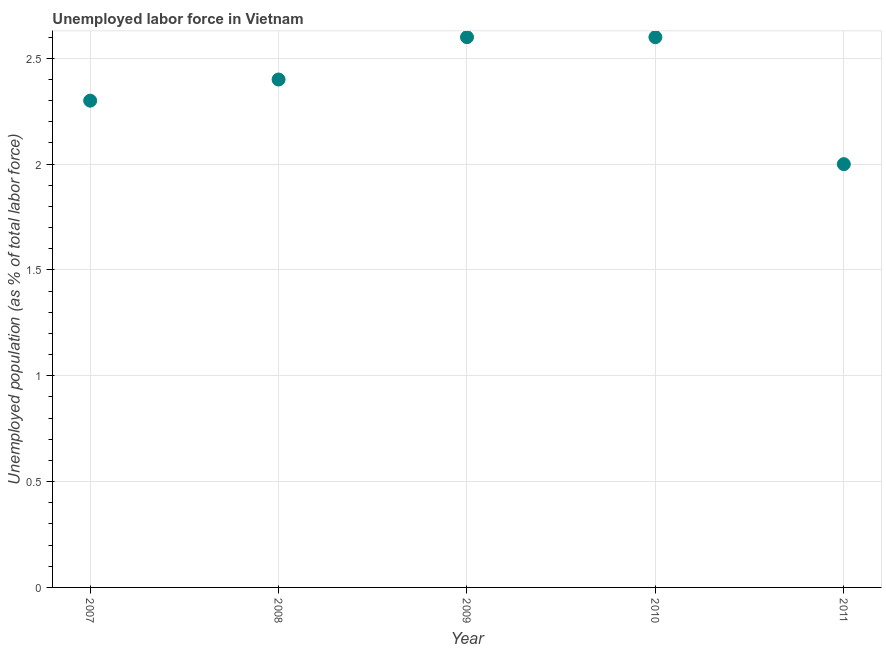What is the total unemployed population in 2007?
Your answer should be compact. 2.3. Across all years, what is the maximum total unemployed population?
Give a very brief answer. 2.6. Across all years, what is the minimum total unemployed population?
Offer a terse response. 2. In which year was the total unemployed population minimum?
Make the answer very short. 2011. What is the sum of the total unemployed population?
Provide a short and direct response. 11.9. What is the difference between the total unemployed population in 2008 and 2010?
Give a very brief answer. -0.2. What is the average total unemployed population per year?
Make the answer very short. 2.38. What is the median total unemployed population?
Provide a short and direct response. 2.4. In how many years, is the total unemployed population greater than 1 %?
Your answer should be very brief. 5. Do a majority of the years between 2009 and 2007 (inclusive) have total unemployed population greater than 1.5 %?
Give a very brief answer. No. What is the ratio of the total unemployed population in 2010 to that in 2011?
Ensure brevity in your answer.  1.3. Is the total unemployed population in 2008 less than that in 2010?
Provide a succinct answer. Yes. What is the difference between the highest and the second highest total unemployed population?
Give a very brief answer. 0. What is the difference between the highest and the lowest total unemployed population?
Your response must be concise. 0.6. How many dotlines are there?
Make the answer very short. 1. How many years are there in the graph?
Your answer should be very brief. 5. What is the difference between two consecutive major ticks on the Y-axis?
Give a very brief answer. 0.5. Does the graph contain grids?
Your response must be concise. Yes. What is the title of the graph?
Ensure brevity in your answer.  Unemployed labor force in Vietnam. What is the label or title of the Y-axis?
Your response must be concise. Unemployed population (as % of total labor force). What is the Unemployed population (as % of total labor force) in 2007?
Offer a terse response. 2.3. What is the Unemployed population (as % of total labor force) in 2008?
Offer a very short reply. 2.4. What is the Unemployed population (as % of total labor force) in 2009?
Ensure brevity in your answer.  2.6. What is the Unemployed population (as % of total labor force) in 2010?
Provide a succinct answer. 2.6. What is the Unemployed population (as % of total labor force) in 2011?
Make the answer very short. 2. What is the difference between the Unemployed population (as % of total labor force) in 2007 and 2011?
Keep it short and to the point. 0.3. What is the difference between the Unemployed population (as % of total labor force) in 2008 and 2009?
Provide a succinct answer. -0.2. What is the difference between the Unemployed population (as % of total labor force) in 2009 and 2010?
Provide a short and direct response. 0. What is the difference between the Unemployed population (as % of total labor force) in 2009 and 2011?
Your answer should be very brief. 0.6. What is the ratio of the Unemployed population (as % of total labor force) in 2007 to that in 2008?
Offer a terse response. 0.96. What is the ratio of the Unemployed population (as % of total labor force) in 2007 to that in 2009?
Provide a succinct answer. 0.89. What is the ratio of the Unemployed population (as % of total labor force) in 2007 to that in 2010?
Give a very brief answer. 0.89. What is the ratio of the Unemployed population (as % of total labor force) in 2007 to that in 2011?
Your answer should be compact. 1.15. What is the ratio of the Unemployed population (as % of total labor force) in 2008 to that in 2009?
Ensure brevity in your answer.  0.92. What is the ratio of the Unemployed population (as % of total labor force) in 2008 to that in 2010?
Give a very brief answer. 0.92. What is the ratio of the Unemployed population (as % of total labor force) in 2008 to that in 2011?
Your response must be concise. 1.2. What is the ratio of the Unemployed population (as % of total labor force) in 2009 to that in 2010?
Your answer should be compact. 1. 